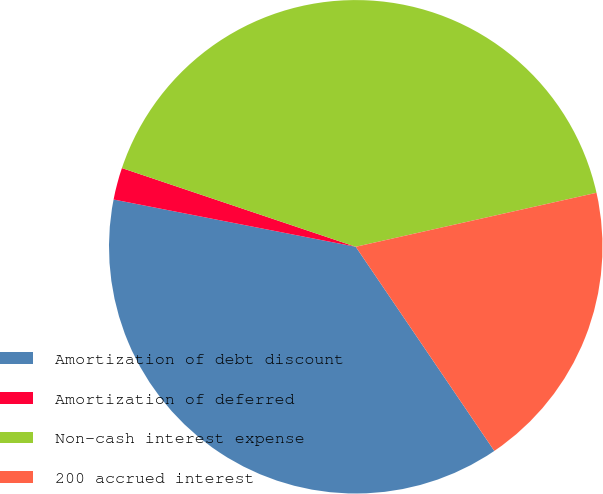Convert chart to OTSL. <chart><loc_0><loc_0><loc_500><loc_500><pie_chart><fcel>Amortization of debt discount<fcel>Amortization of deferred<fcel>Non-cash interest expense<fcel>200 accrued interest<nl><fcel>37.56%<fcel>2.1%<fcel>41.32%<fcel>19.02%<nl></chart> 